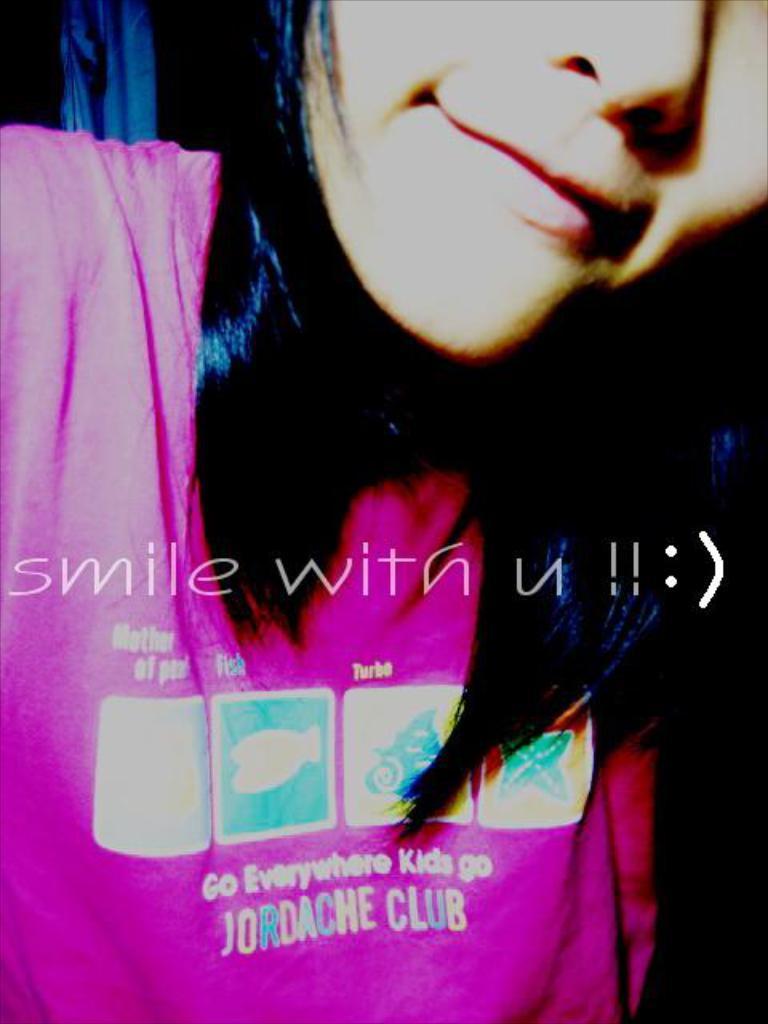Can you describe this image briefly? In this image we can see a lady, there are images and text on her t-shirt, also we can see some text on the image. 